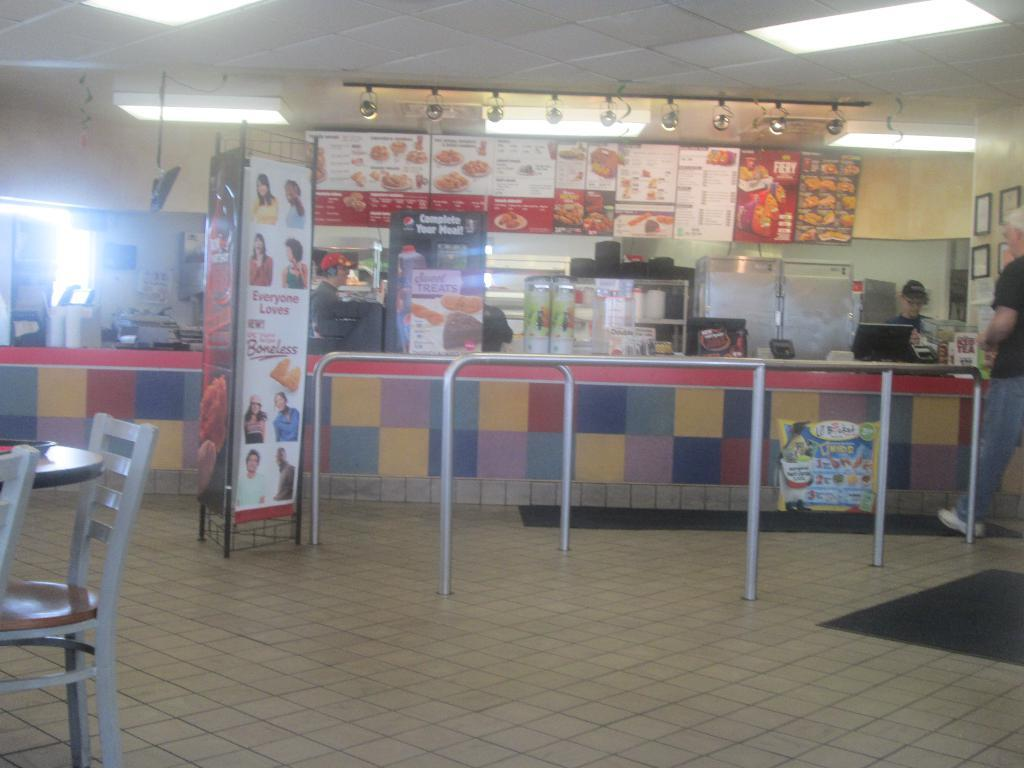What type of space is depicted in the image? There is a room in the image. What can be found on a board in the room? There is a menu on a board in the room. Where is the menu located? The menu is located at an ordering area. Can you describe the man's position in the room? The man is in a corner of the room. What furniture is present in the room? There is a table with chairs in the room. Where are the table and chairs located in relation to the menu? The table and chairs are on the other end of the room. What type of mailbox can be seen in the image? There is no mailbox present in the image. Can you describe the lift in the room? There is no lift present in the image. 